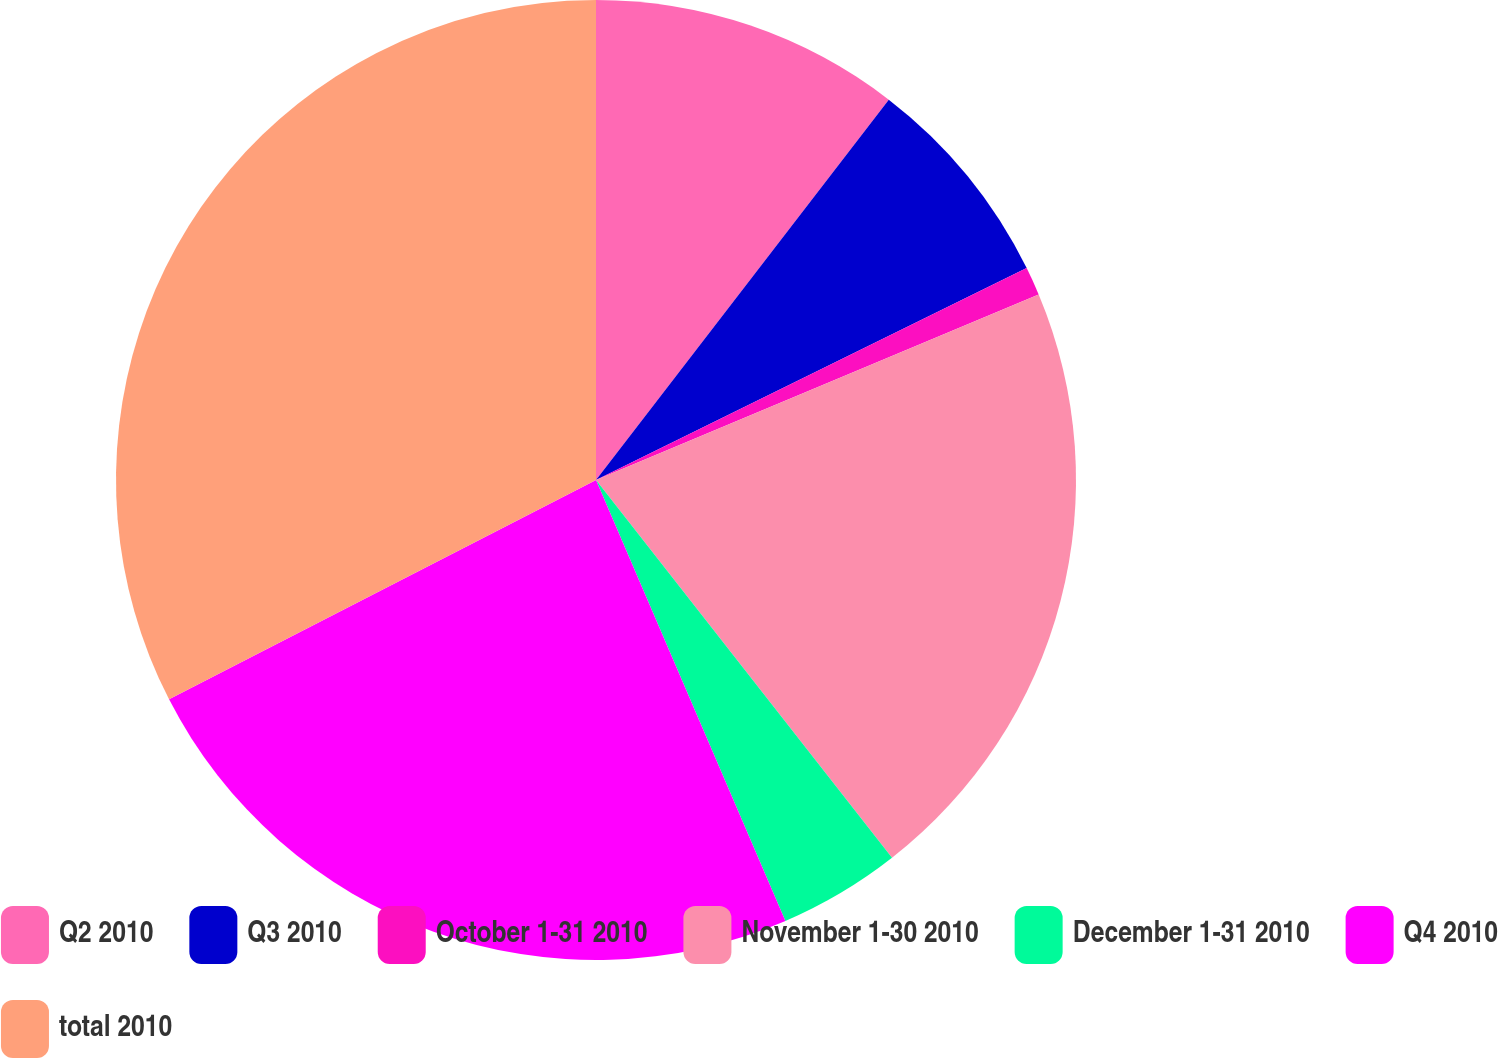<chart> <loc_0><loc_0><loc_500><loc_500><pie_chart><fcel>Q2 2010<fcel>Q3 2010<fcel>October 1-31 2010<fcel>November 1-30 2010<fcel>December 1-31 2010<fcel>Q4 2010<fcel>total 2010<nl><fcel>10.44%<fcel>7.28%<fcel>0.96%<fcel>20.74%<fcel>4.12%<fcel>23.9%<fcel>32.55%<nl></chart> 